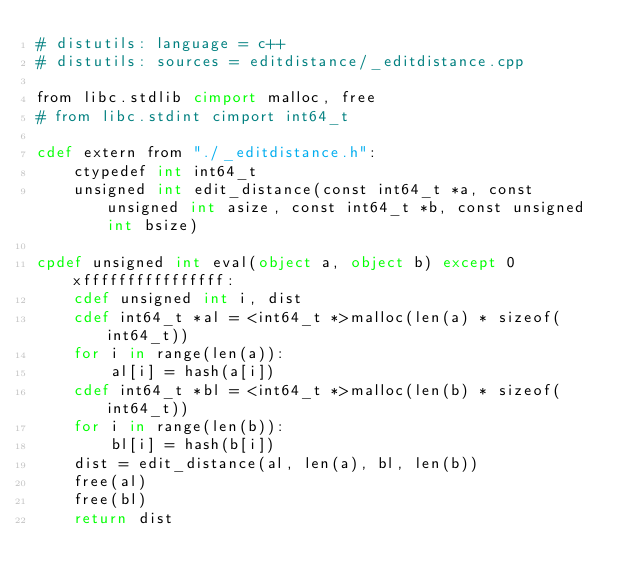<code> <loc_0><loc_0><loc_500><loc_500><_Cython_># distutils: language = c++
# distutils: sources = editdistance/_editdistance.cpp

from libc.stdlib cimport malloc, free
# from libc.stdint cimport int64_t

cdef extern from "./_editdistance.h":
    ctypedef int int64_t
    unsigned int edit_distance(const int64_t *a, const unsigned int asize, const int64_t *b, const unsigned int bsize)

cpdef unsigned int eval(object a, object b) except 0xffffffffffffffff:
    cdef unsigned int i, dist
    cdef int64_t *al = <int64_t *>malloc(len(a) * sizeof(int64_t))
    for i in range(len(a)):
        al[i] = hash(a[i])
    cdef int64_t *bl = <int64_t *>malloc(len(b) * sizeof(int64_t))
    for i in range(len(b)):
        bl[i] = hash(b[i])
    dist = edit_distance(al, len(a), bl, len(b))
    free(al)
    free(bl)
    return dist
</code> 